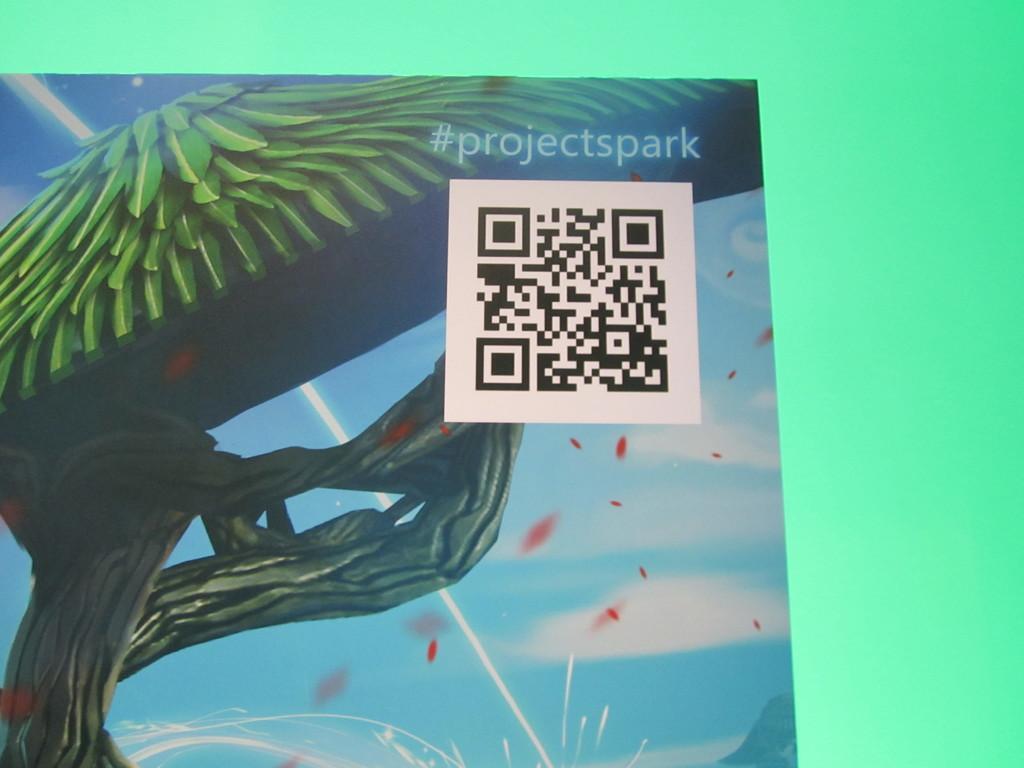Could you give a brief overview of what you see in this image? On this poster there is a tree, QR code and watermark. Background it is in green color. 